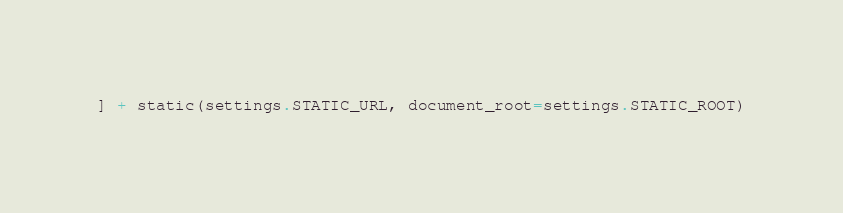Convert code to text. <code><loc_0><loc_0><loc_500><loc_500><_Python_>] + static(settings.STATIC_URL, document_root=settings.STATIC_ROOT)

</code> 